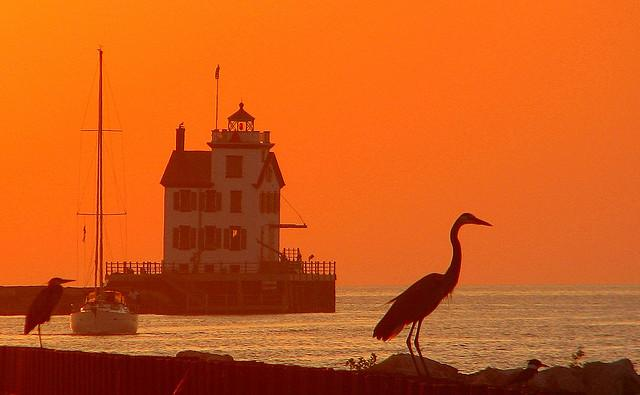Which animal is most similar to the animal on the right?

Choices:
A) manx
B) echidna
C) egret
D) salamander egret 